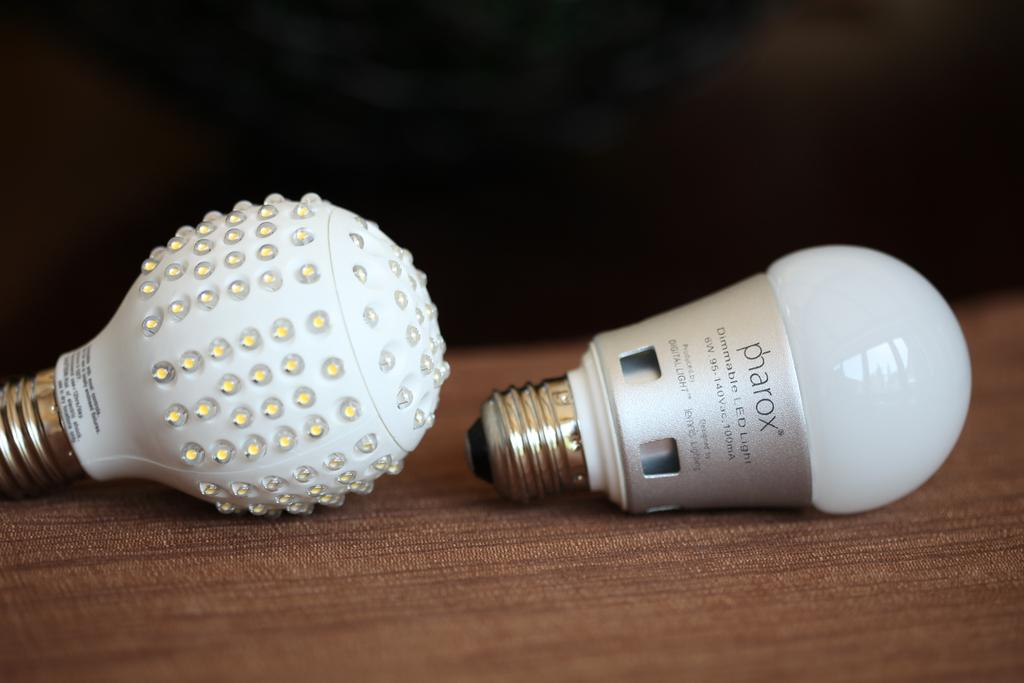What objects are present in the image that emit light? There are two bulbs in the image that emit light. What color are the bulbs in the image? The bulbs in the image are white in color. Is there any text or writing on the bulbs? Yes, there is text or writing on the bulbs. How many chairs can be seen in the image? There are no chairs present in the image. Is there a flock of birds visible in the image? There is no flock of birds present in the image. 